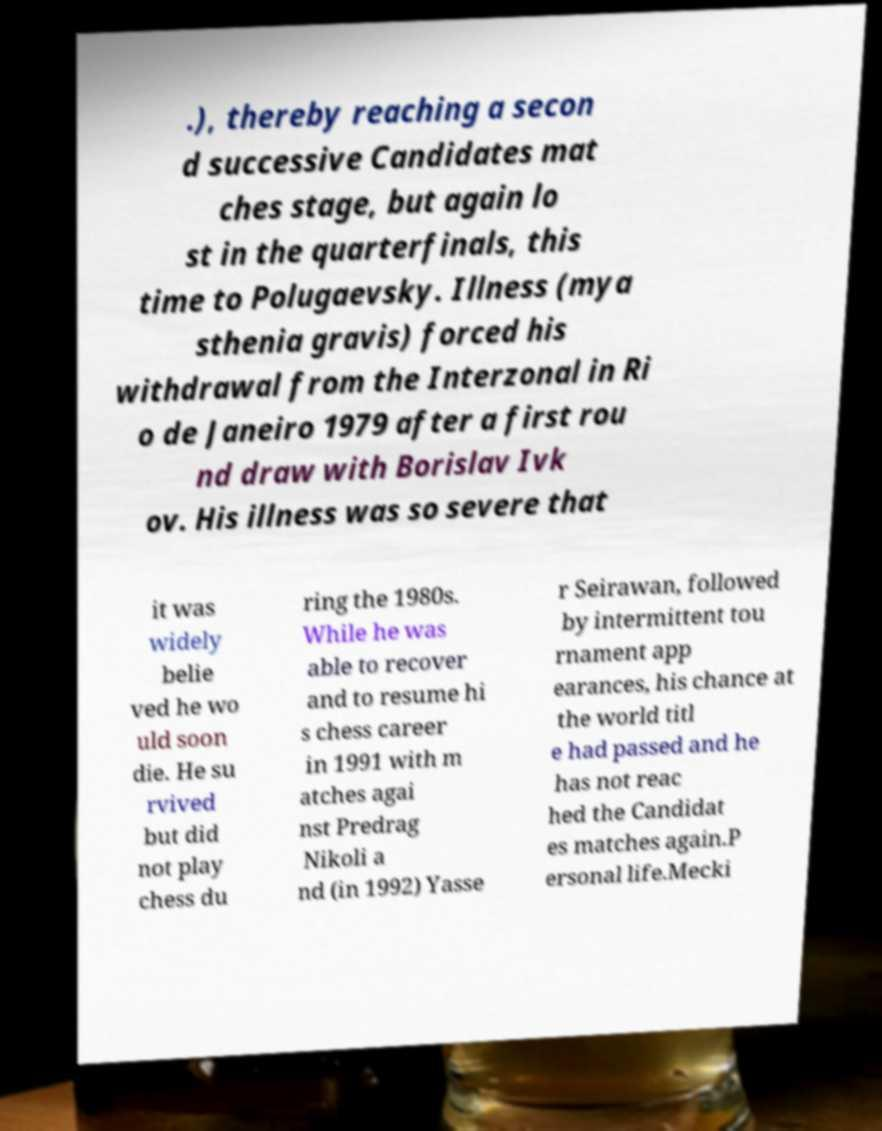Please read and relay the text visible in this image. What does it say? .), thereby reaching a secon d successive Candidates mat ches stage, but again lo st in the quarterfinals, this time to Polugaevsky. Illness (mya sthenia gravis) forced his withdrawal from the Interzonal in Ri o de Janeiro 1979 after a first rou nd draw with Borislav Ivk ov. His illness was so severe that it was widely belie ved he wo uld soon die. He su rvived but did not play chess du ring the 1980s. While he was able to recover and to resume hi s chess career in 1991 with m atches agai nst Predrag Nikoli a nd (in 1992) Yasse r Seirawan, followed by intermittent tou rnament app earances, his chance at the world titl e had passed and he has not reac hed the Candidat es matches again.P ersonal life.Mecki 